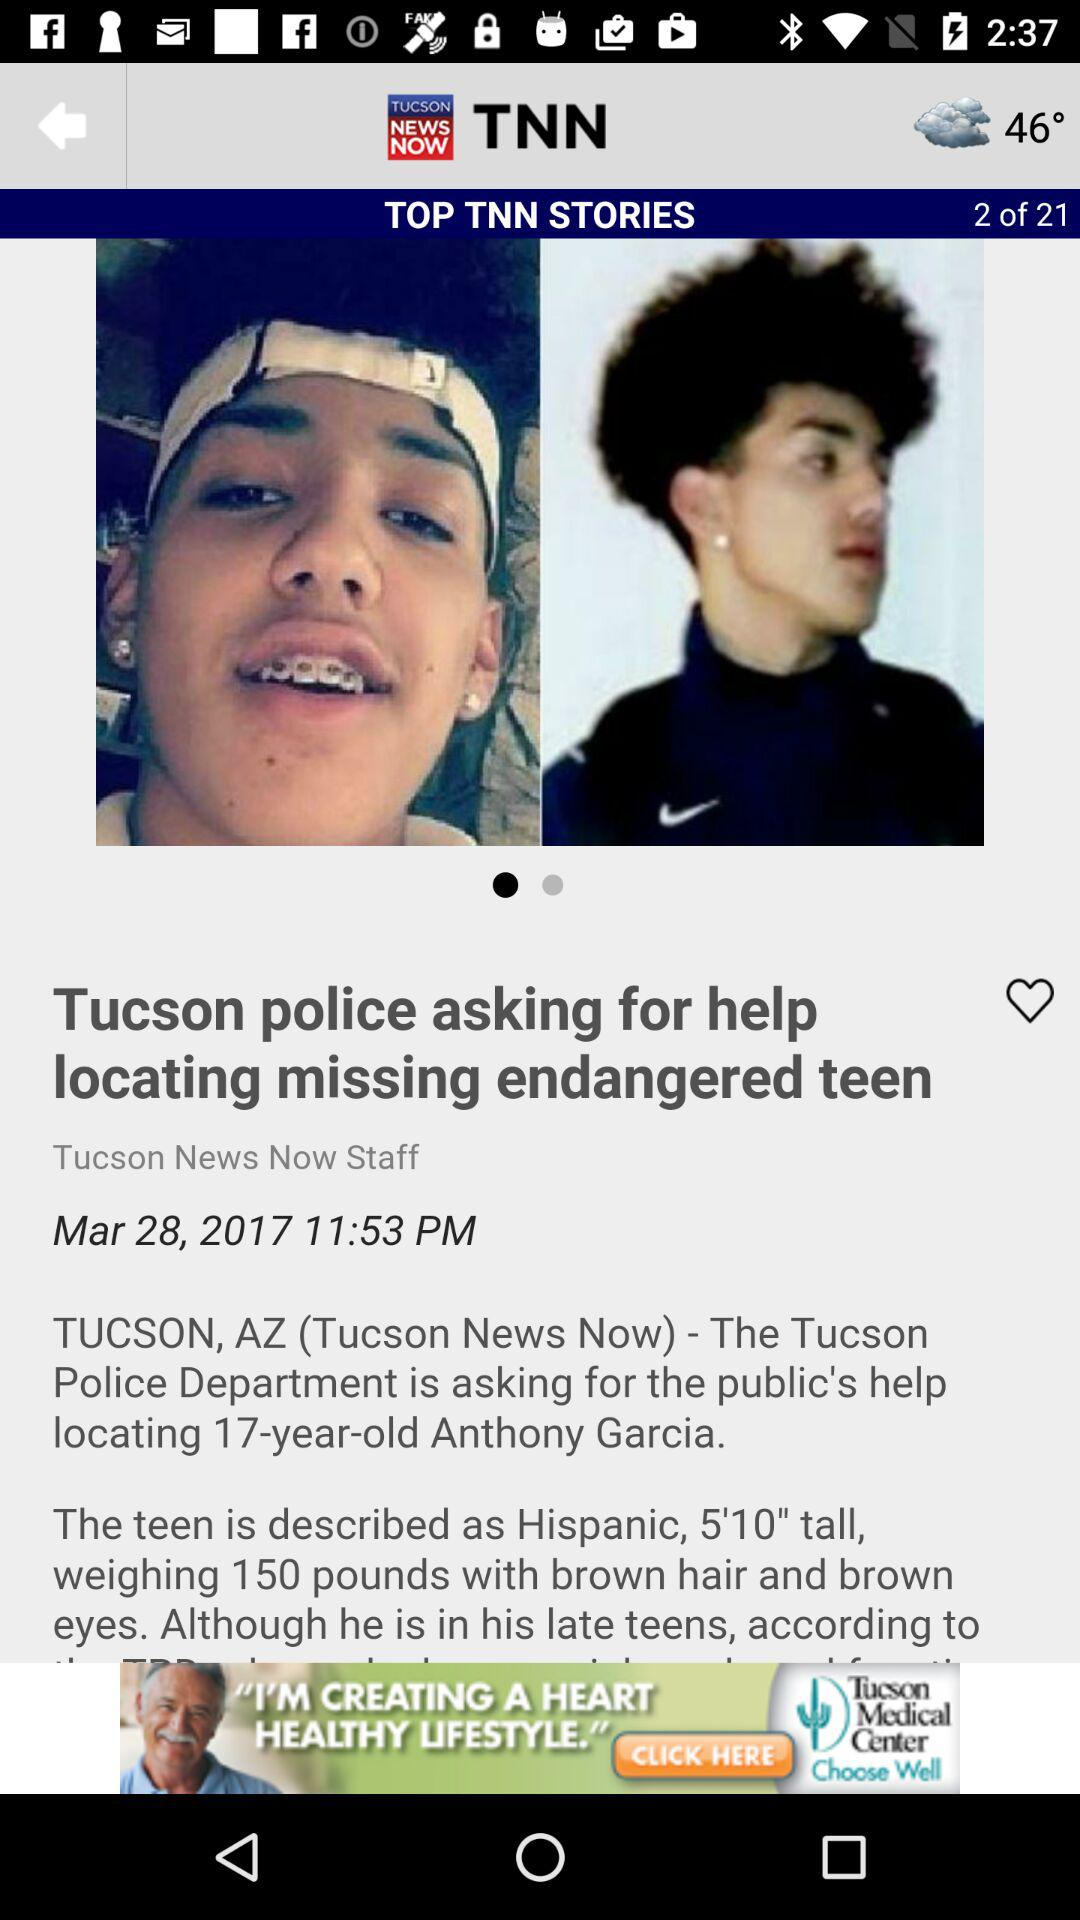What is the published time of the article? The published time of the article is 11:53 PM. 